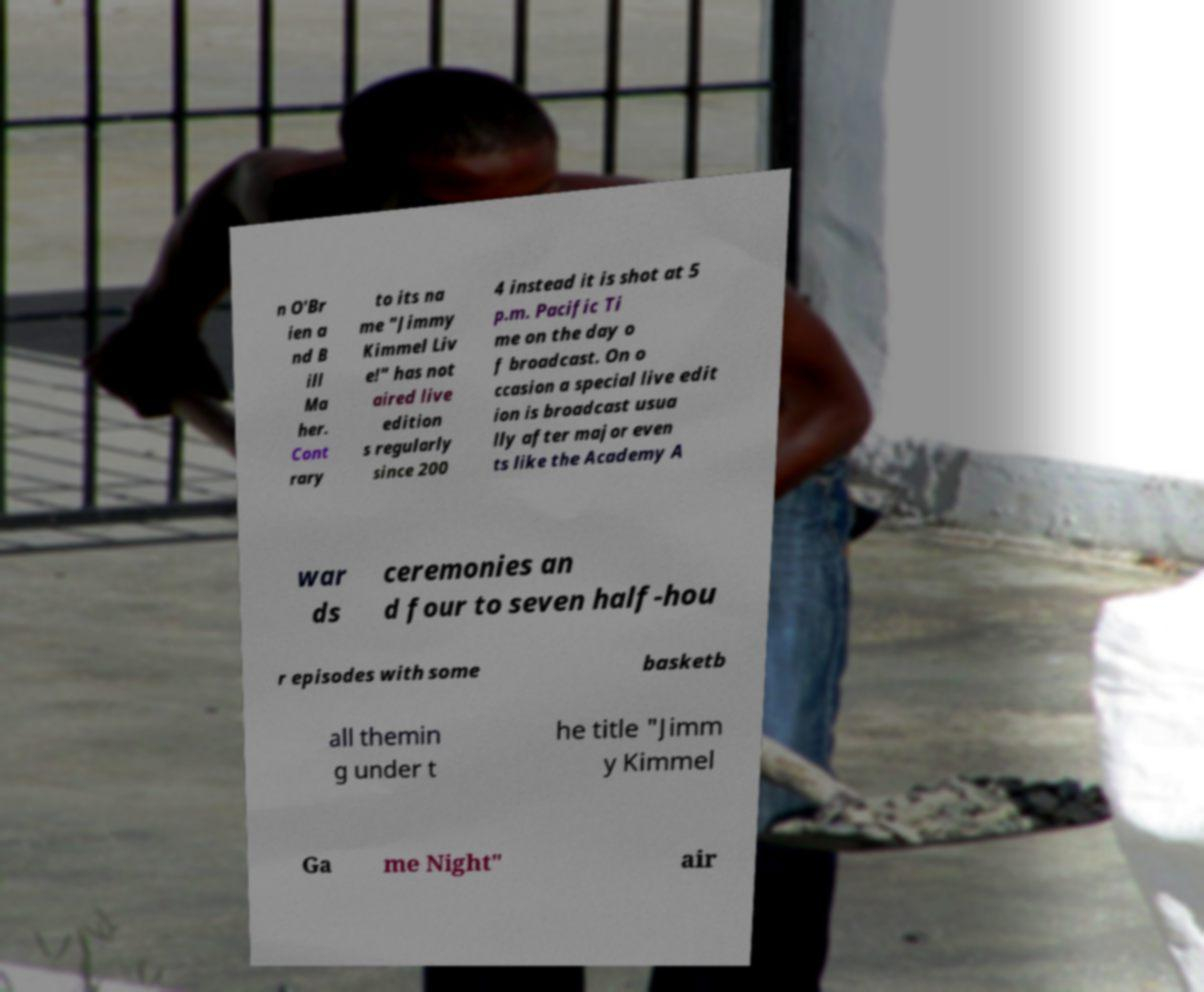Could you assist in decoding the text presented in this image and type it out clearly? n O'Br ien a nd B ill Ma her. Cont rary to its na me "Jimmy Kimmel Liv e!" has not aired live edition s regularly since 200 4 instead it is shot at 5 p.m. Pacific Ti me on the day o f broadcast. On o ccasion a special live edit ion is broadcast usua lly after major even ts like the Academy A war ds ceremonies an d four to seven half-hou r episodes with some basketb all themin g under t he title "Jimm y Kimmel Ga me Night" air 